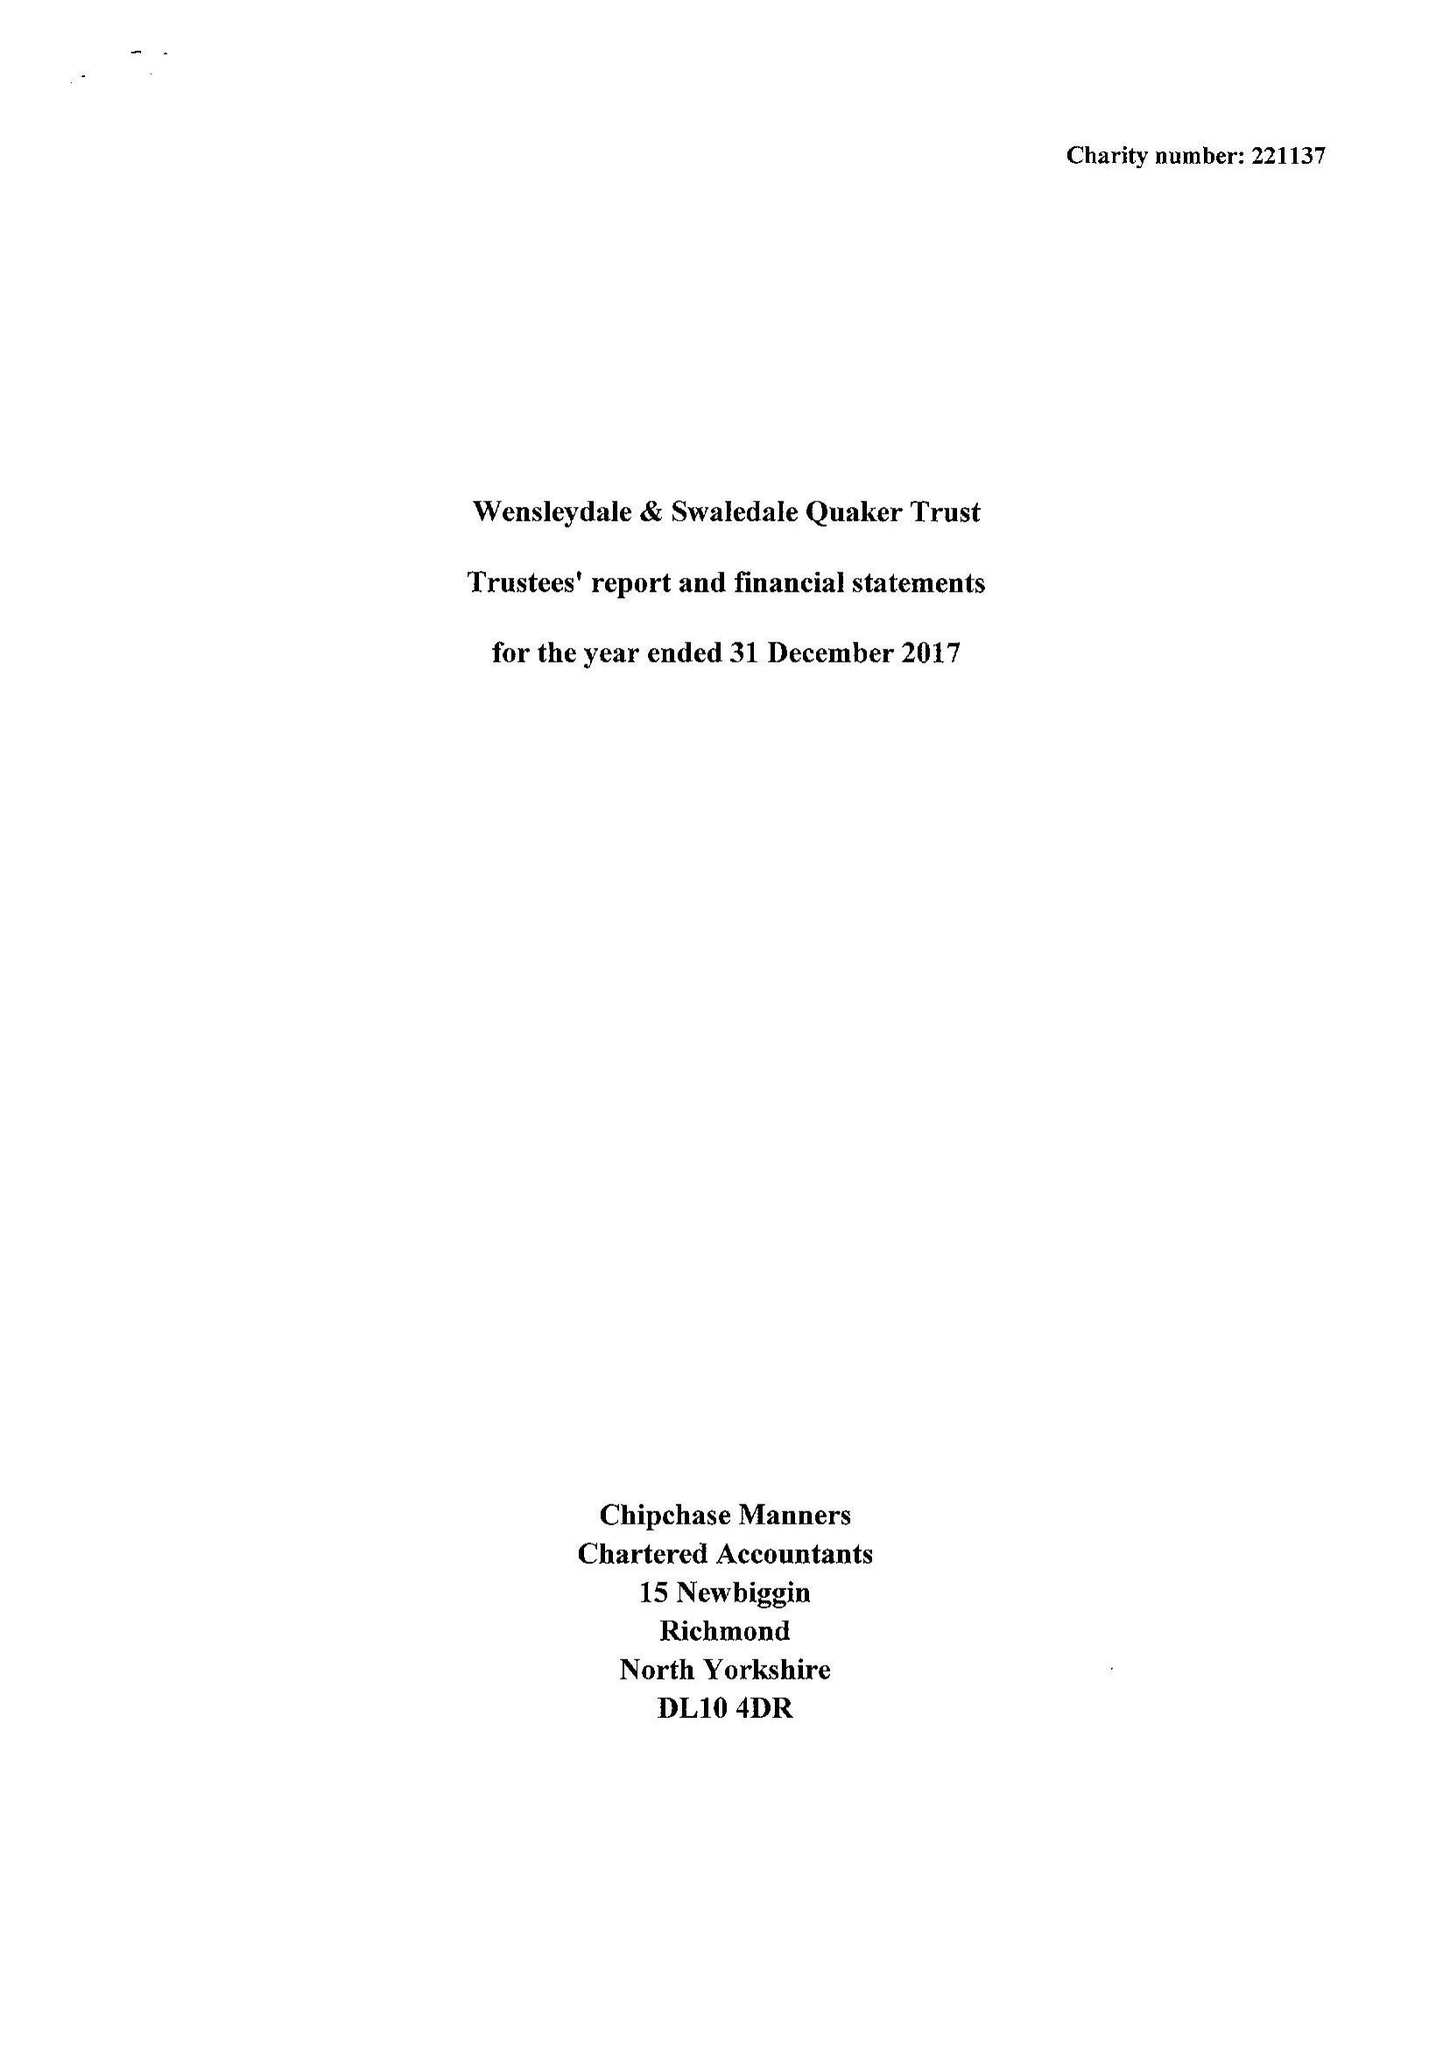What is the value for the spending_annually_in_british_pounds?
Answer the question using a single word or phrase. 42668.00 